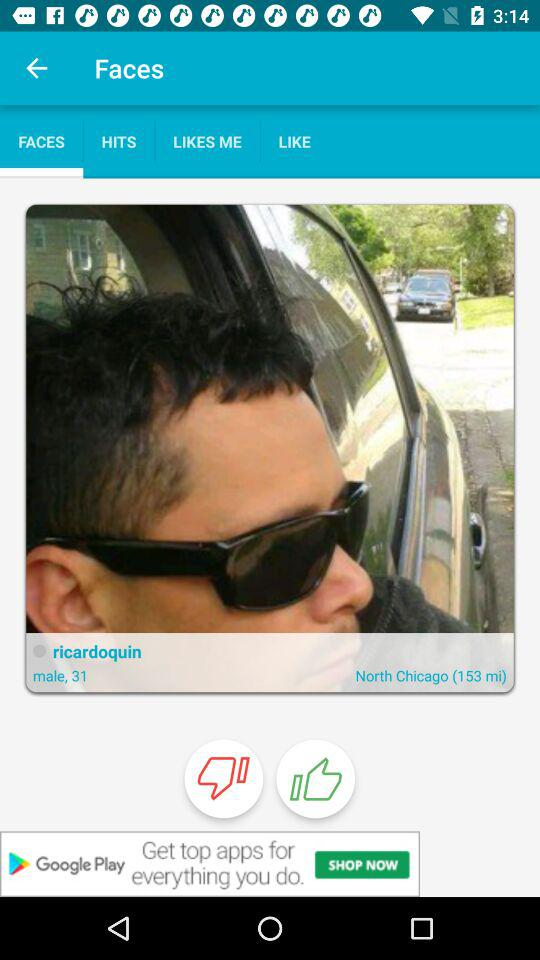What is the height of ricardoquin?
When the provided information is insufficient, respond with <no answer>. <no answer> 